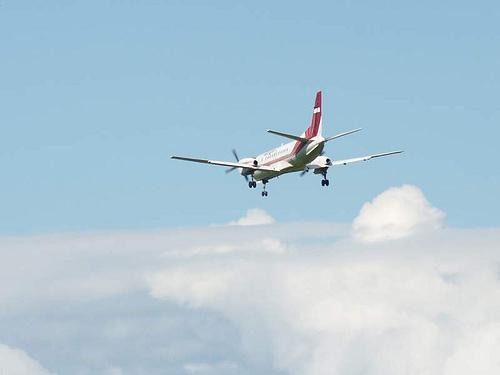How many engines does the plane have?
Give a very brief answer. 2. How many wings does the plane have?
Give a very brief answer. 2. 